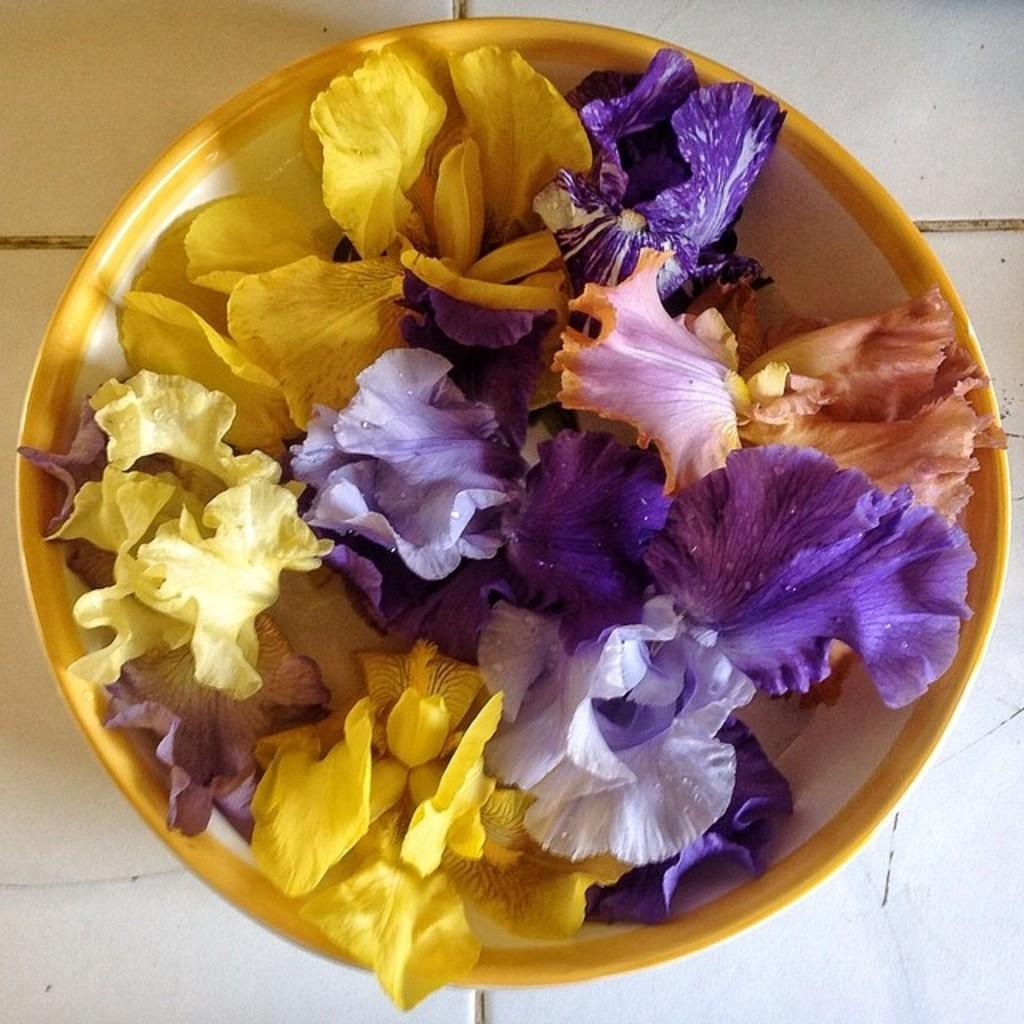Can you describe this image briefly? In this image we can see a bowl containing flowers placed on the table. 